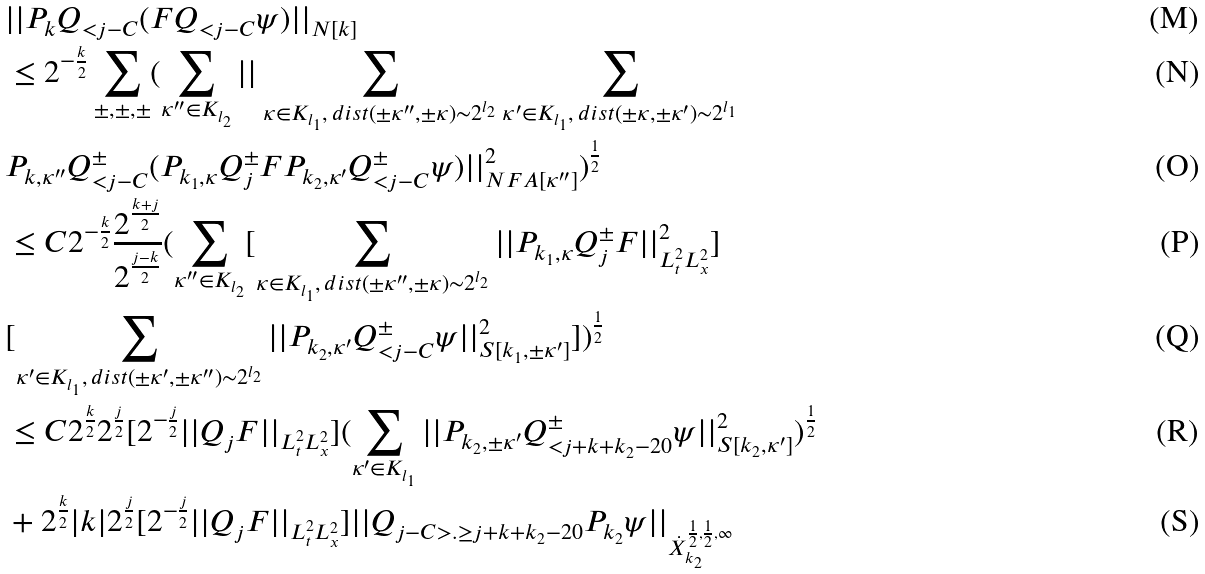Convert formula to latex. <formula><loc_0><loc_0><loc_500><loc_500>& | | P _ { k } Q _ { < j - C } ( F Q _ { < j - C } \psi ) | | _ { N [ k ] } \\ & \leq 2 ^ { - \frac { k } { 2 } } \sum _ { \pm , \pm , \pm } ( \sum _ { \kappa ^ { \prime \prime } \in K _ { l _ { 2 } } } | | \sum _ { \kappa \in K _ { l _ { 1 } } , \, d i s t ( \pm \kappa ^ { \prime \prime } , \pm \kappa ) \sim 2 ^ { l _ { 2 } } } \sum _ { \kappa ^ { \prime } \in K _ { l _ { 1 } } , \, d i s t ( \pm \kappa , \pm \kappa ^ { \prime } ) \sim 2 ^ { l _ { 1 } } } \\ & P _ { k , \kappa ^ { \prime \prime } } Q ^ { \pm } _ { < j - C } ( P _ { k _ { 1 } , \kappa } Q ^ { \pm } _ { j } F P _ { k _ { 2 } , \kappa ^ { \prime } } Q ^ { \pm } _ { < j - C } \psi ) | | _ { N F A [ \kappa ^ { \prime \prime } ] } ^ { 2 } ) ^ { \frac { 1 } { 2 } } \\ & \leq C 2 ^ { - \frac { k } { 2 } } \frac { 2 ^ { \frac { k + j } { 2 } } } { 2 ^ { \frac { j - k } { 2 } } } ( \sum _ { \kappa ^ { \prime \prime } \in K _ { l _ { 2 } } } [ \sum _ { \kappa \in K _ { l _ { 1 } } , \, d i s t ( \pm \kappa ^ { \prime \prime } , \pm \kappa ) \sim 2 ^ { l _ { 2 } } } | | P _ { k _ { 1 } , \kappa } Q ^ { \pm } _ { j } F | | _ { L _ { t } ^ { 2 } L _ { x } ^ { 2 } } ^ { 2 } ] \\ & [ \sum _ { \kappa ^ { \prime } \in K _ { l _ { 1 } } , \, d i s t ( \pm \kappa ^ { \prime } , \pm \kappa ^ { \prime \prime } ) \sim 2 ^ { l _ { 2 } } } | | P _ { k _ { 2 } , \kappa ^ { \prime } } Q ^ { \pm } _ { < j - C } \psi | | _ { S [ k _ { 1 } , \pm \kappa ^ { \prime } ] } ^ { 2 } ] ) ^ { \frac { 1 } { 2 } } \\ & \leq C 2 ^ { \frac { k } { 2 } } 2 ^ { \frac { j } { 2 } } [ 2 ^ { - \frac { j } { 2 } } | | Q _ { j } F | | _ { L _ { t } ^ { 2 } L _ { x } ^ { 2 } } ] ( \sum _ { \kappa ^ { \prime } \in K _ { l _ { 1 } } } | | P _ { k _ { 2 } , \pm \kappa ^ { \prime } } Q ^ { \pm } _ { < j + k + k _ { 2 } - 2 0 } \psi | | _ { S [ k _ { 2 } , \kappa ^ { \prime } ] } ^ { 2 } ) ^ { \frac { 1 } { 2 } } \\ & + 2 ^ { \frac { k } { 2 } } | k | 2 ^ { \frac { j } { 2 } } [ 2 ^ { - \frac { j } { 2 } } | | Q _ { j } F | | _ { L _ { t } ^ { 2 } L _ { x } ^ { 2 } } ] | | Q _ { j - C > . \geq j + k + k _ { 2 } - 2 0 } P _ { k _ { 2 } } \psi | | _ { \dot { X } _ { k _ { 2 } } ^ { \frac { 1 } { 2 } , \frac { 1 } { 2 } , \infty } }</formula> 